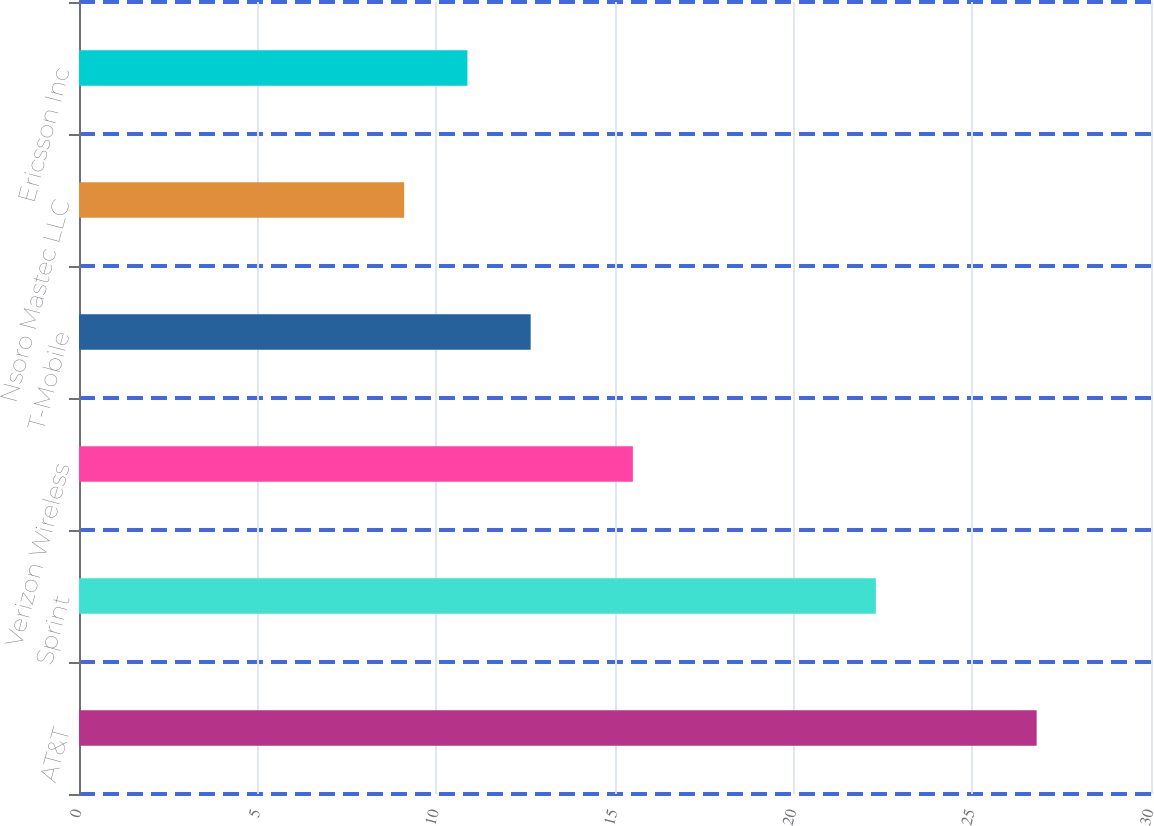<chart> <loc_0><loc_0><loc_500><loc_500><bar_chart><fcel>AT&T<fcel>Sprint<fcel>Verizon Wireless<fcel>T-Mobile<fcel>Nsoro Mastec LLC<fcel>Ericsson Inc<nl><fcel>26.8<fcel>22.3<fcel>15.5<fcel>12.64<fcel>9.1<fcel>10.87<nl></chart> 